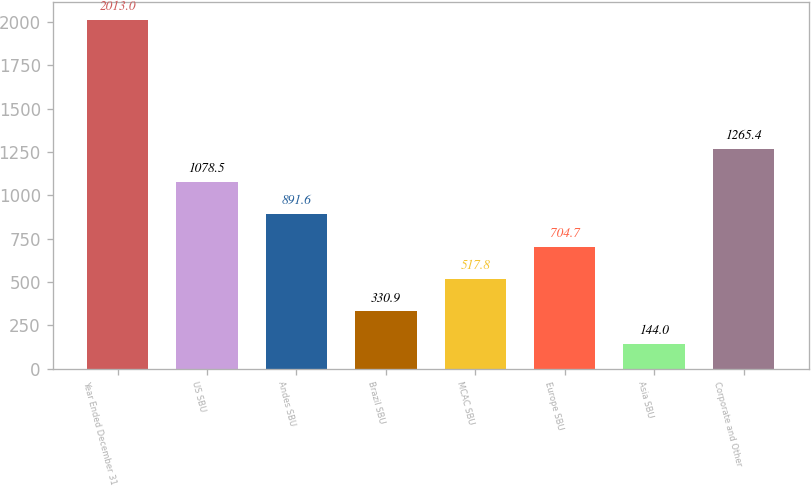Convert chart. <chart><loc_0><loc_0><loc_500><loc_500><bar_chart><fcel>Year Ended December 31<fcel>US SBU<fcel>Andes SBU<fcel>Brazil SBU<fcel>MCAC SBU<fcel>Europe SBU<fcel>Asia SBU<fcel>Corporate and Other<nl><fcel>2013<fcel>1078.5<fcel>891.6<fcel>330.9<fcel>517.8<fcel>704.7<fcel>144<fcel>1265.4<nl></chart> 